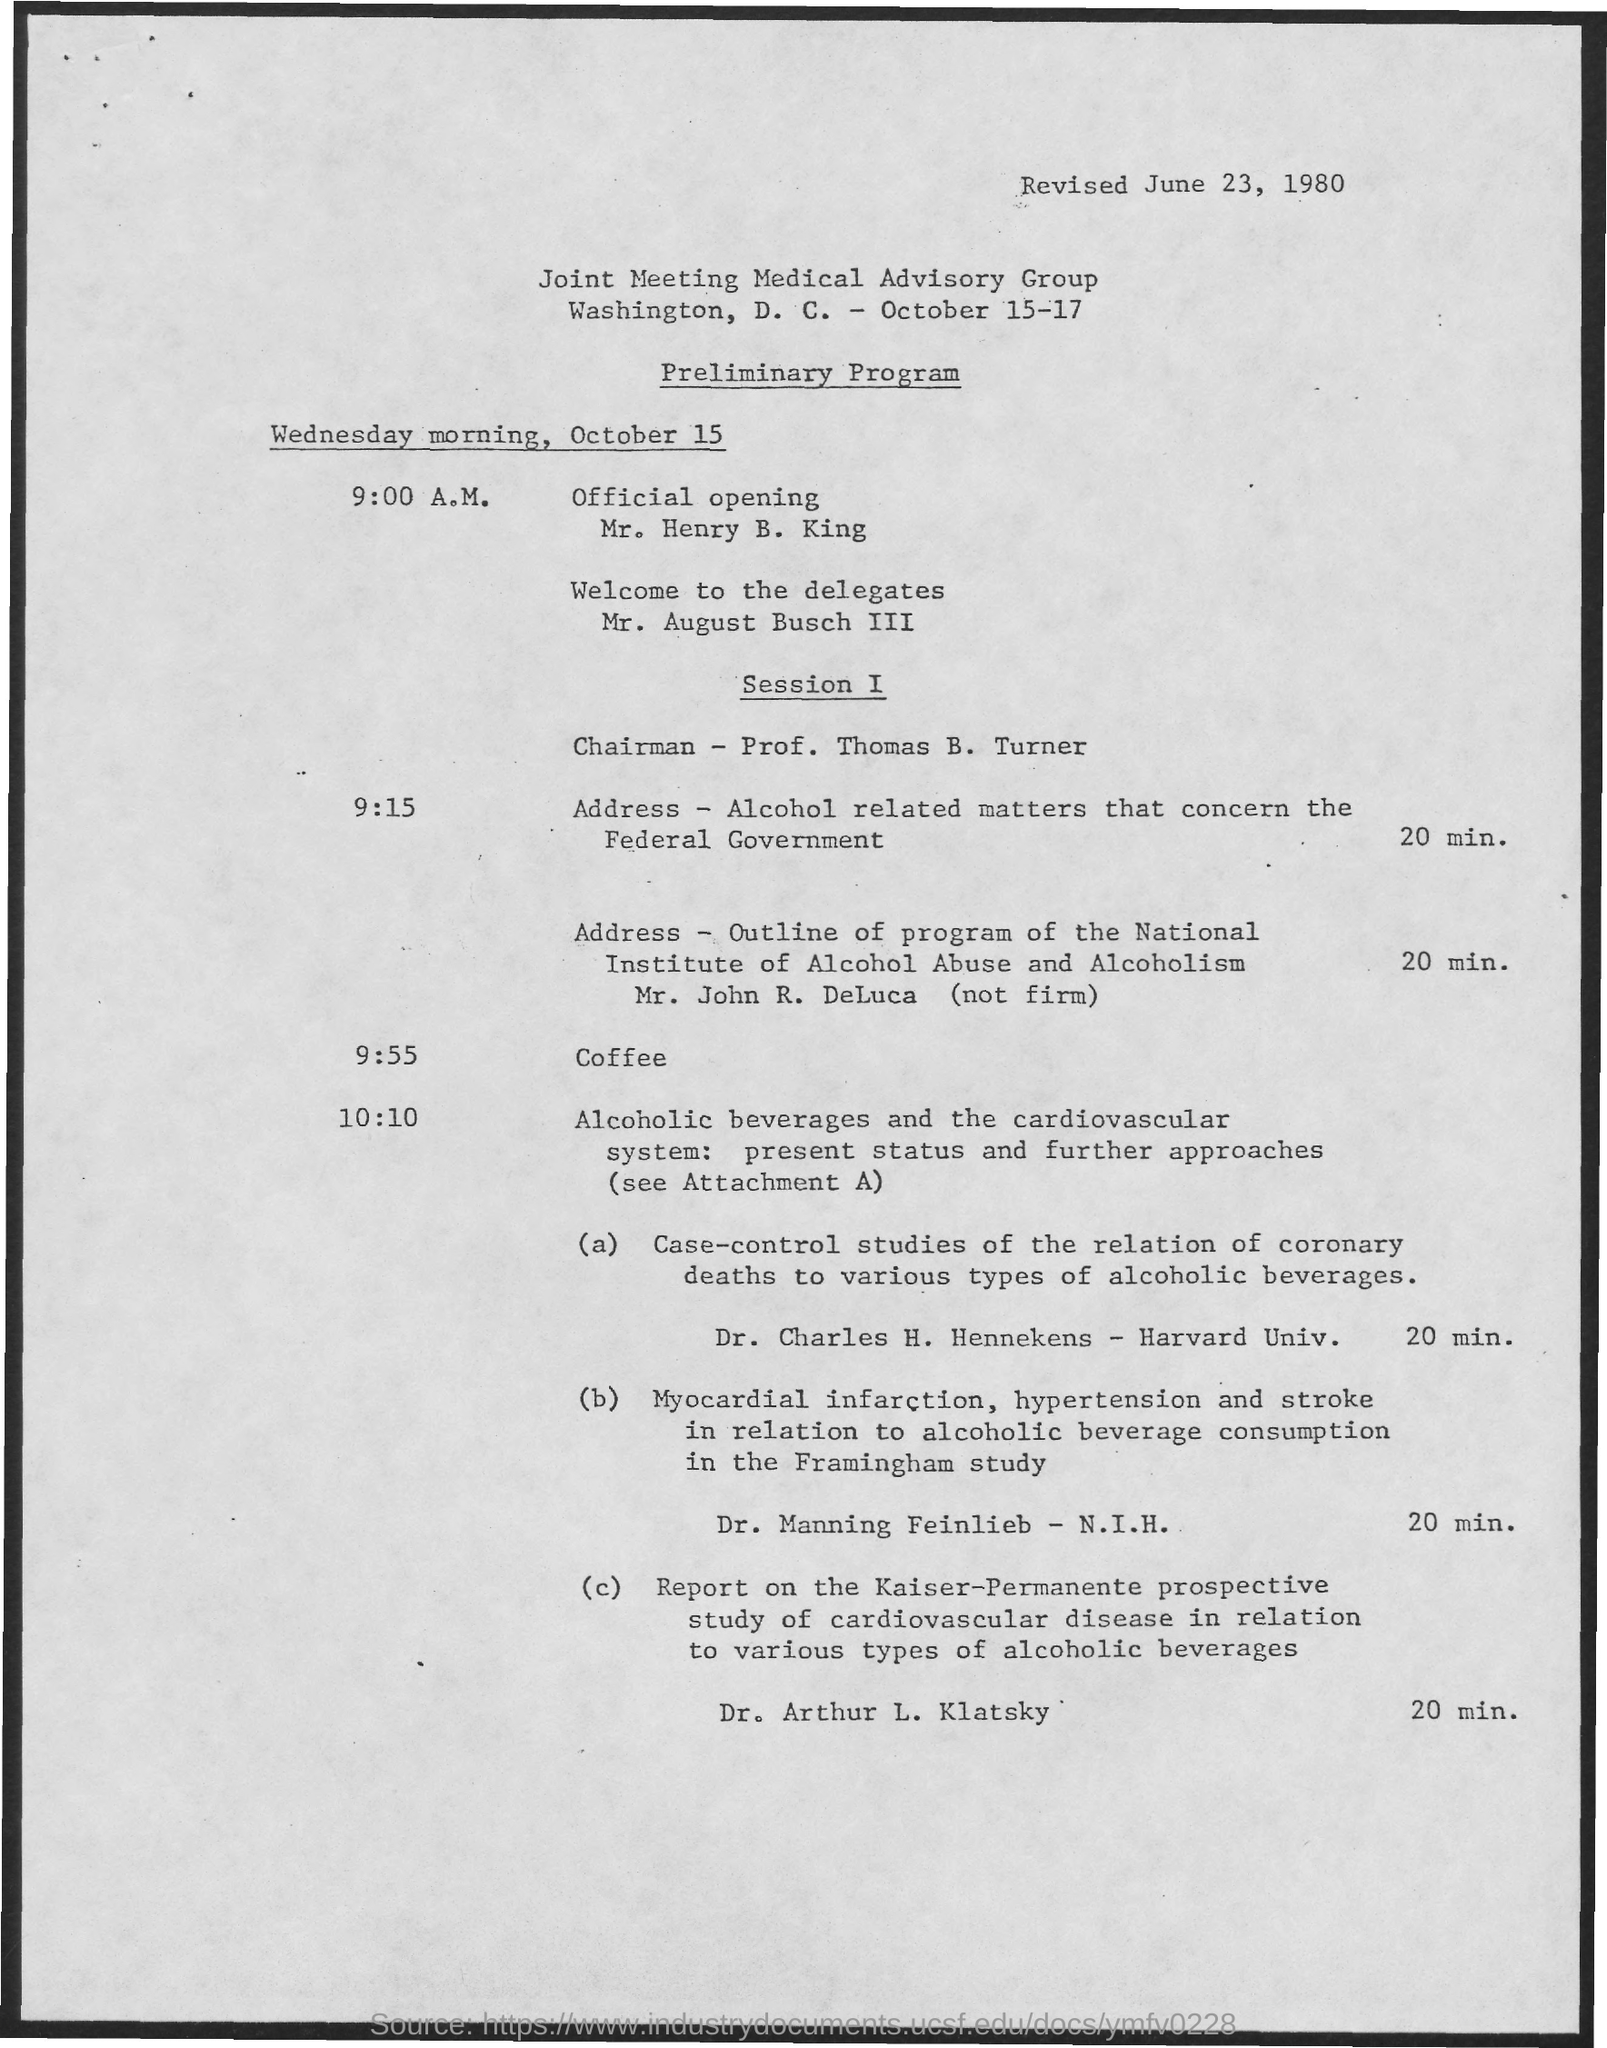Give some essential details in this illustration. What is Coffee Time? It is currently 9:55 AM. The revised date is June 23, 1980. 